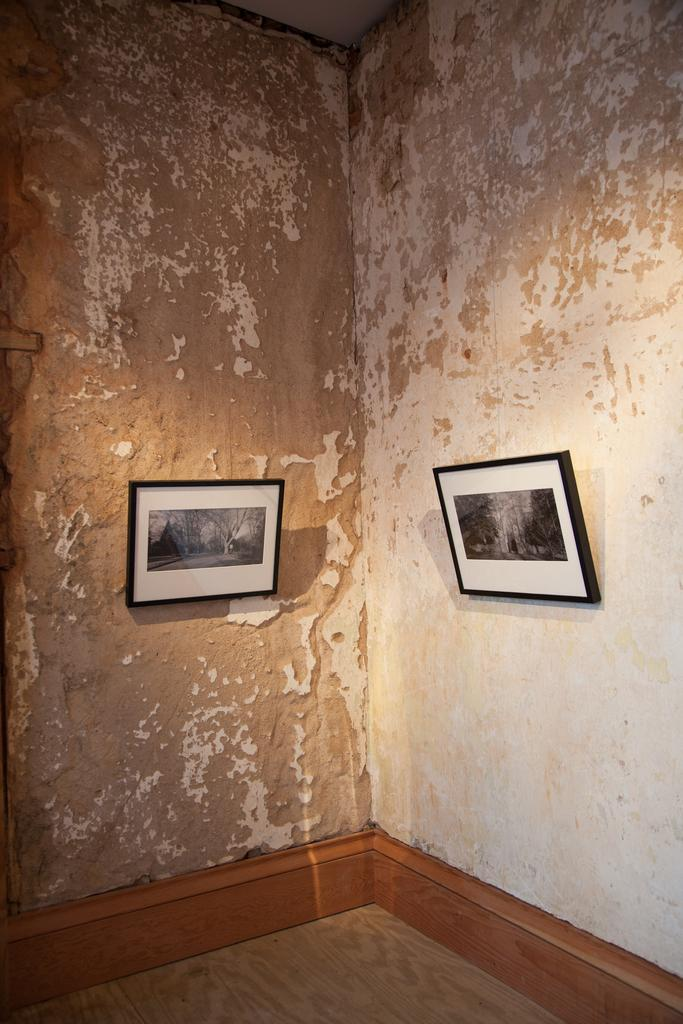How many photo frames can be seen in the image? There are two photo frames in the image. Where are the photo frames located? The photo frames are on the wall. What type of paste is used to attach the photo frames to the wall in the image? There is no information about the type of paste used to attach the photo frames to the wall in the image. What type of crate is visible in the image? There is no crate present in the image. 